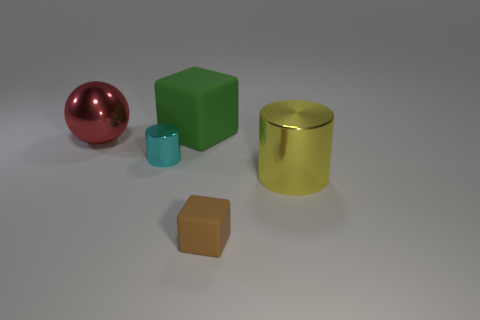How many large green things are made of the same material as the cyan thing? There are no large green objects made of the same material as the small cyan object. The large green object in the image is a matte cube, whereas the cyan object appears to be a glossy cylinder. 